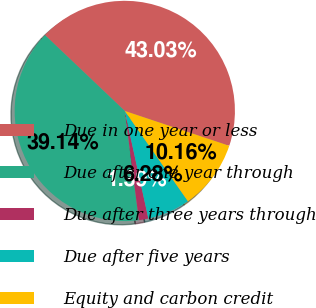Convert chart. <chart><loc_0><loc_0><loc_500><loc_500><pie_chart><fcel>Due in one year or less<fcel>Due after one year through<fcel>Due after three years through<fcel>Due after five years<fcel>Equity and carbon credit<nl><fcel>43.03%<fcel>39.14%<fcel>1.39%<fcel>6.28%<fcel>10.16%<nl></chart> 